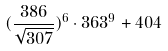Convert formula to latex. <formula><loc_0><loc_0><loc_500><loc_500>( \frac { 3 8 6 } { \sqrt { 3 0 7 } } ) ^ { 6 } \cdot 3 6 3 ^ { 9 } + 4 0 4</formula> 